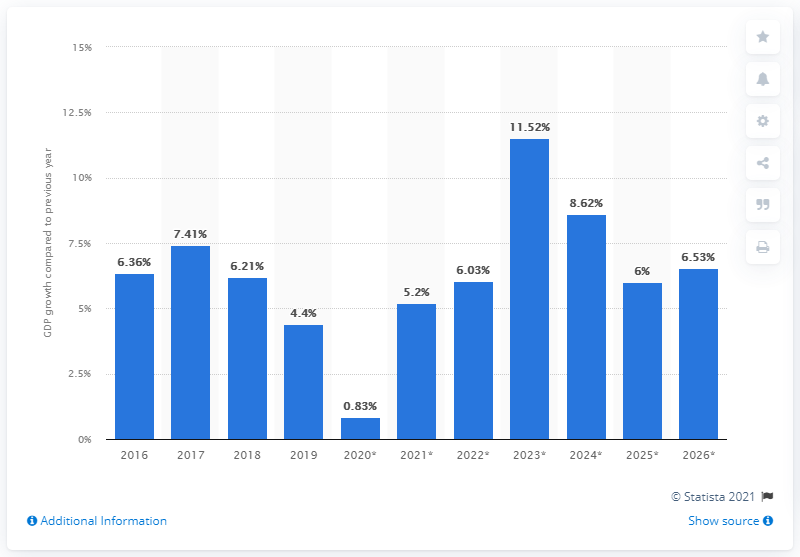Draw attention to some important aspects in this diagram. Senegal's real Gross Domestic Product (GDP) increased by 4.4% in 2019. 